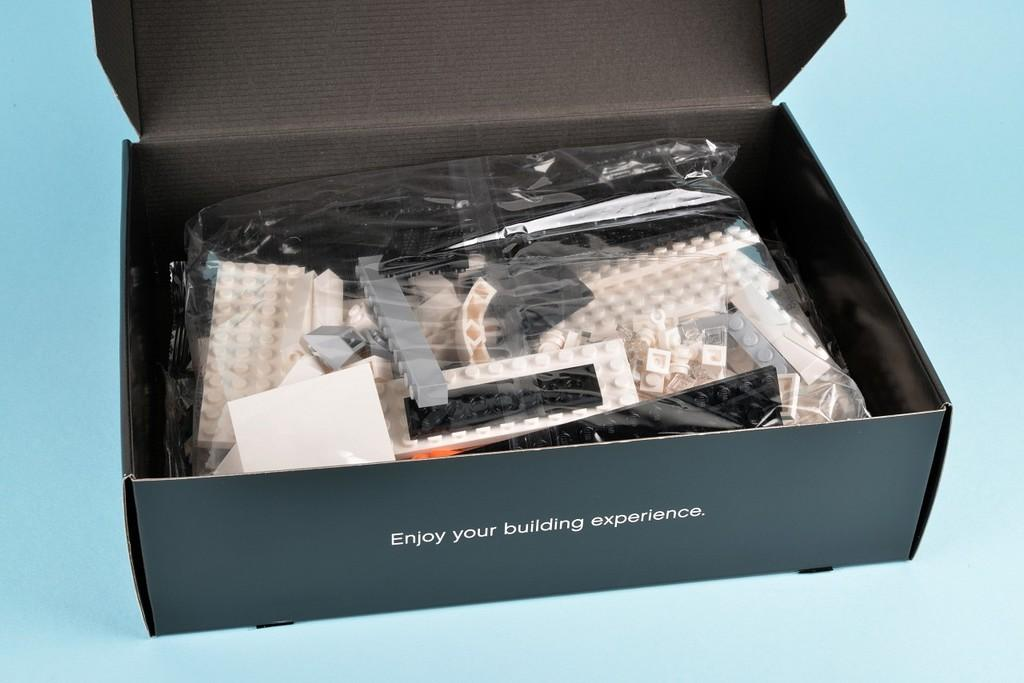<image>
Present a compact description of the photo's key features. An open box that is black and full of legos that says enjoy your building experience. 